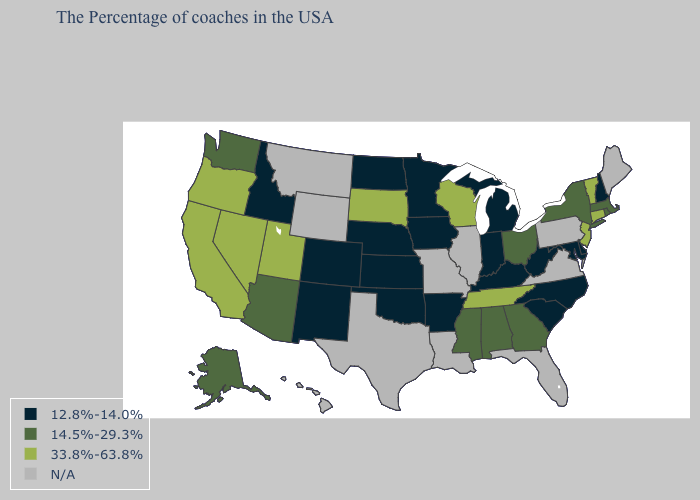What is the highest value in the USA?
Short answer required. 33.8%-63.8%. Name the states that have a value in the range N/A?
Give a very brief answer. Maine, Pennsylvania, Virginia, Florida, Illinois, Louisiana, Missouri, Texas, Wyoming, Montana, Hawaii. What is the value of Alaska?
Give a very brief answer. 14.5%-29.3%. Which states have the lowest value in the South?
Give a very brief answer. Delaware, Maryland, North Carolina, South Carolina, West Virginia, Kentucky, Arkansas, Oklahoma. What is the lowest value in the USA?
Be succinct. 12.8%-14.0%. Does New Hampshire have the lowest value in the Northeast?
Keep it brief. Yes. What is the lowest value in the USA?
Answer briefly. 12.8%-14.0%. Among the states that border New York , which have the highest value?
Keep it brief. Vermont, Connecticut, New Jersey. What is the value of Kansas?
Answer briefly. 12.8%-14.0%. Among the states that border Illinois , which have the highest value?
Be succinct. Wisconsin. What is the value of Missouri?
Concise answer only. N/A. Among the states that border Kentucky , does Indiana have the lowest value?
Give a very brief answer. Yes. 